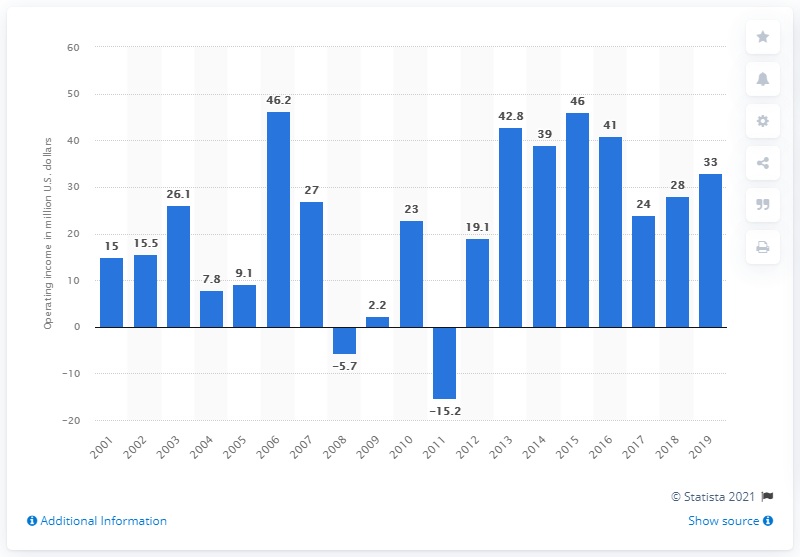Identify some key points in this picture. The operating income of the Las Vegas Raiders during the 2019 season was $33 million. 